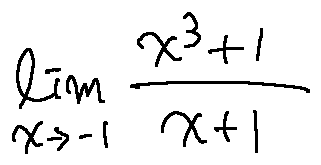Convert formula to latex. <formula><loc_0><loc_0><loc_500><loc_500>\lim \lim i t s _ { x \rightarrow - 1 } \frac { x ^ { 3 } + 1 } { x + 1 }</formula> 